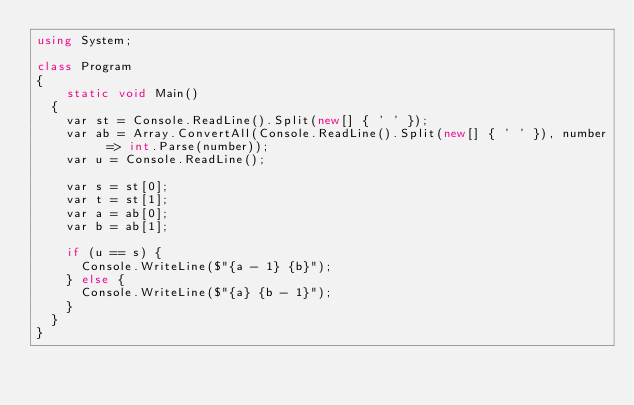<code> <loc_0><loc_0><loc_500><loc_500><_C#_>using System;

class Program
{
    static void Main()
	{
		var st = Console.ReadLine().Split(new[] { ' ' });
		var ab = Array.ConvertAll(Console.ReadLine().Split(new[] { ' ' }), number => int.Parse(number));
		var u = Console.ReadLine();

		var s = st[0];
		var t = st[1];
		var a = ab[0];
		var b = ab[1];

		if (u == s) {
			Console.WriteLine($"{a - 1} {b}");
		} else {
			Console.WriteLine($"{a} {b - 1}");
		}
	}
}
</code> 